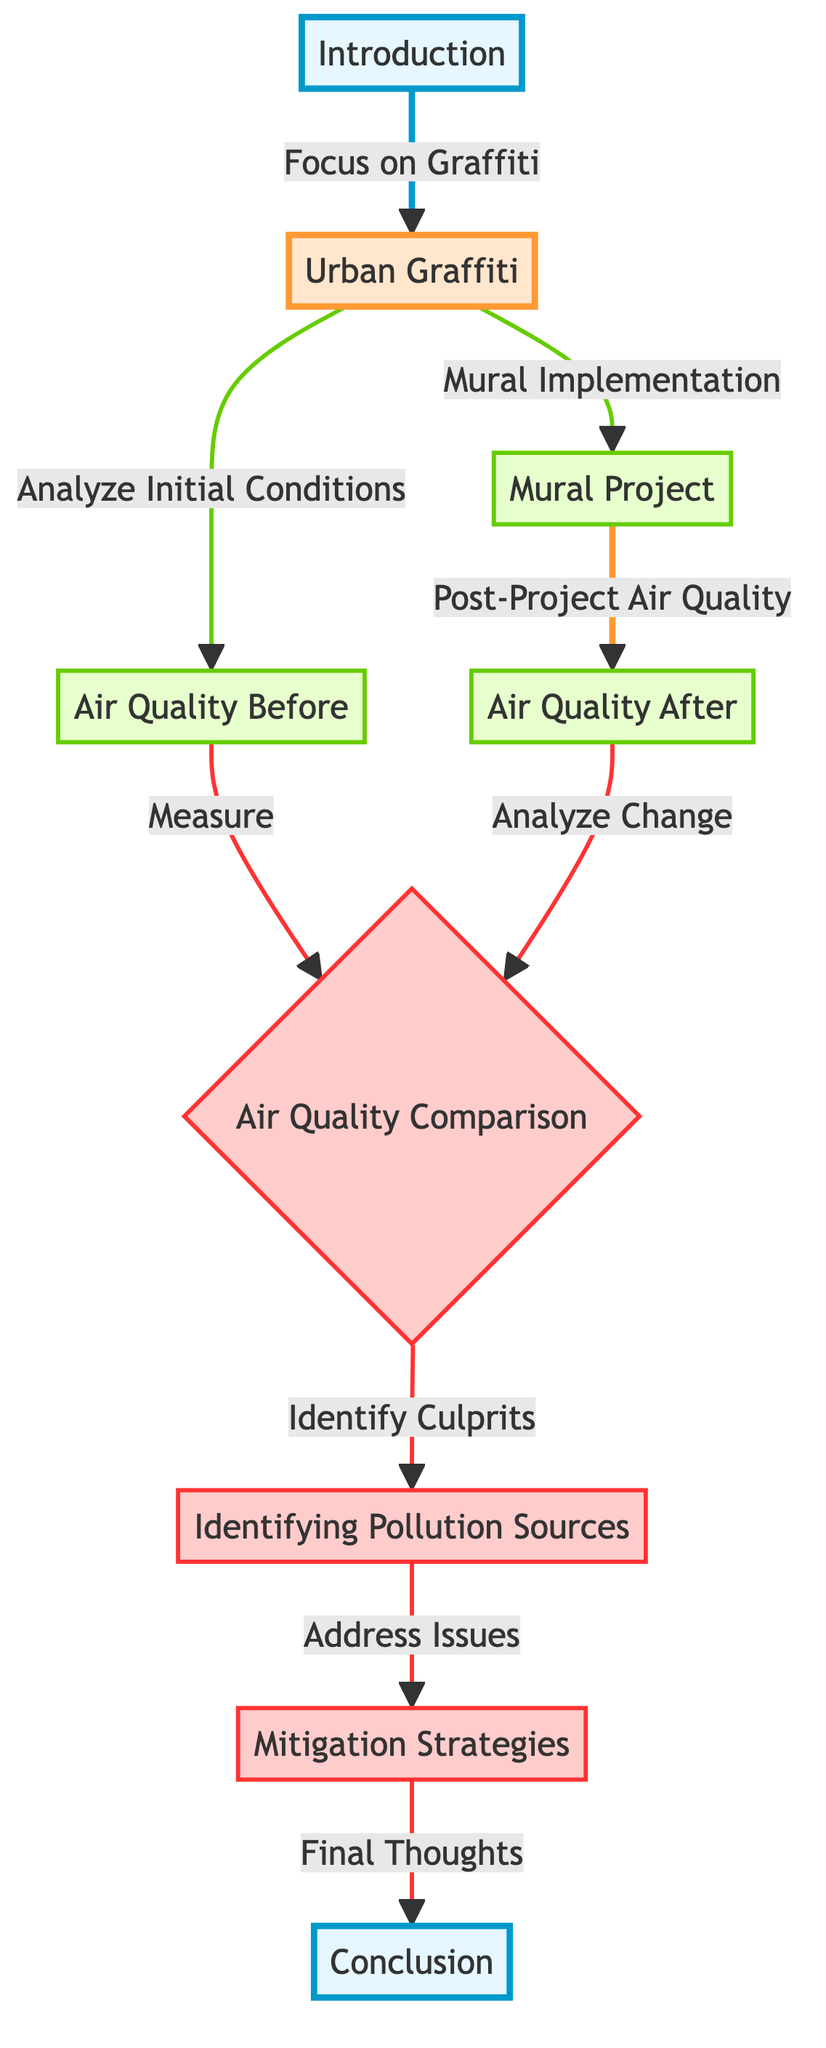What is the starting point of the diagram? The diagram begins at the "Introduction" node, which serves as the starting point in the flowchart.
Answer: Introduction How many main topics are present in the diagram? There is one main topic identified in the diagram, which is "Urban Graffiti."
Answer: One What follows the "Mural Project" node in the diagram? The node that follows "Mural Project" is "Air Quality After." This indicates the next step in the analysis after the mural implementation.
Answer: Air Quality After Which node involves comparing air quality? The "Air Quality Comparison" node involves comparing the air quality before and after the mural project, indicating an evaluative step in the process.
Answer: Air Quality Comparison What action is taken after identifying pollution sources? After identifying pollution sources, the action taken is to address issues, represented by the node "Mitigation Strategies."
Answer: Address Issues How do the nodes "Air Quality Before" and "Air Quality After" relate to the "Air Quality Comparison"? "Air Quality Before" feeds into the comparison by providing initial data, while "Air Quality After" provides data for post-project analysis, both of which are essential for understanding the overall air quality change.
Answer: They feed into the comparison What is the final outcome of the diagram’s process? The final outcome of the diagram's process is represented in the "Conclusion" node, which summarizes the findings and thoughts after all prior steps have been concluded.
Answer: Conclusion What color highlights the key elements in the diagram? The key elements, such as "Air Quality Comparison," "Identifying Pollution Sources," and "Mitigation Strategies," are highlighted in red, which indicates their importance in the discussion.
Answer: Red In how many steps does the analysis proceed from "Air Quality Before" to "Conclusion"? The analysis proceeds in a total of seven steps from "Air Quality Before" through to "Conclusion," as indicated by the connections in the flowchart.
Answer: Seven steps What type of strategies are proposed to deal with pollution sources? "Mitigation Strategies" are proposed to deal with pollution sources identified in the earlier steps of the analysis.
Answer: Mitigation Strategies 